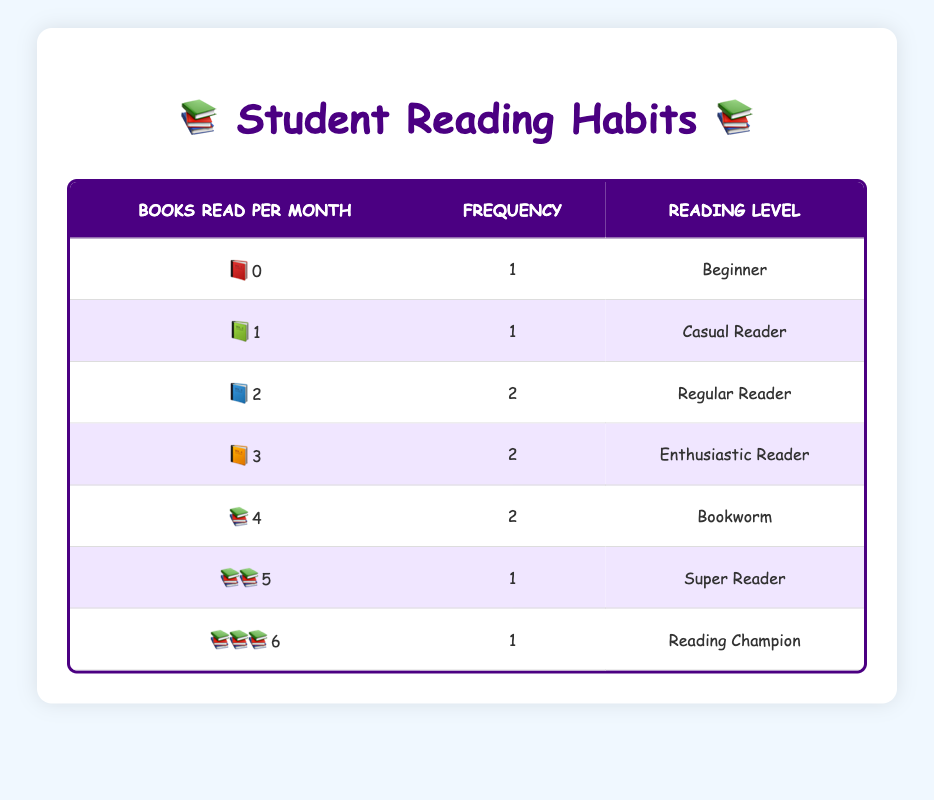What is the highest number of books read per month by a student? By looking at the "Books Read per Month" column, the maximum value is 6, which corresponds to Hannah Lee.
Answer: 6 How many students read 2 books per month? The frequency column shows that there are 2 students who reported reading 2 books per month.
Answer: 2 Is there a student who reads no books at all? Yes, according to the table, Jasmine Patel is listed as reading 0 books per month.
Answer: Yes What is the average number of books read per month by the students? To find the average, sum the values: 0 + 1 + 2 + 2 + 4 + 4 + 5 + 3 + 3 + 6 = 30. Then divide by the number of students (10), which gives 30 / 10 = 3.
Answer: 3 How many students fall into the 'Bookworm' category? The 'Bookworm' category corresponds to students reading 4 books per month; from the frequency column, there are 2 students in this category.
Answer: 2 What is the total number of students who are classified as 'Reading Champion'? According to the description, 'Reading Champion' corresponds to reading 6 books per month, and there is 1 student (Hannah Lee) in this category.
Answer: 1 What percentage of students are classified as 'Regular Readers'? 'Regular Readers' are those reading 2 books per month. There are 2 students in this category out of 10 total students. The percentage is (2/10) * 100 = 20%.
Answer: 20% Which reading category has the same number of students? The categories 'Regular Reader' and 'Enthusiastic Reader' both have 2 students reading 2 and 3 books per month, respectively, indicating they share the same frequency.
Answer: Regular Reader and Enthusiastic Reader If you combine the number of students reading 0, 1, or 2 books per month, how many are there in total? The number of students reading 0 books (1), 1 book (1), and 2 books (2) totals to 1 + 1 + 2 = 4 students combined.
Answer: 4 